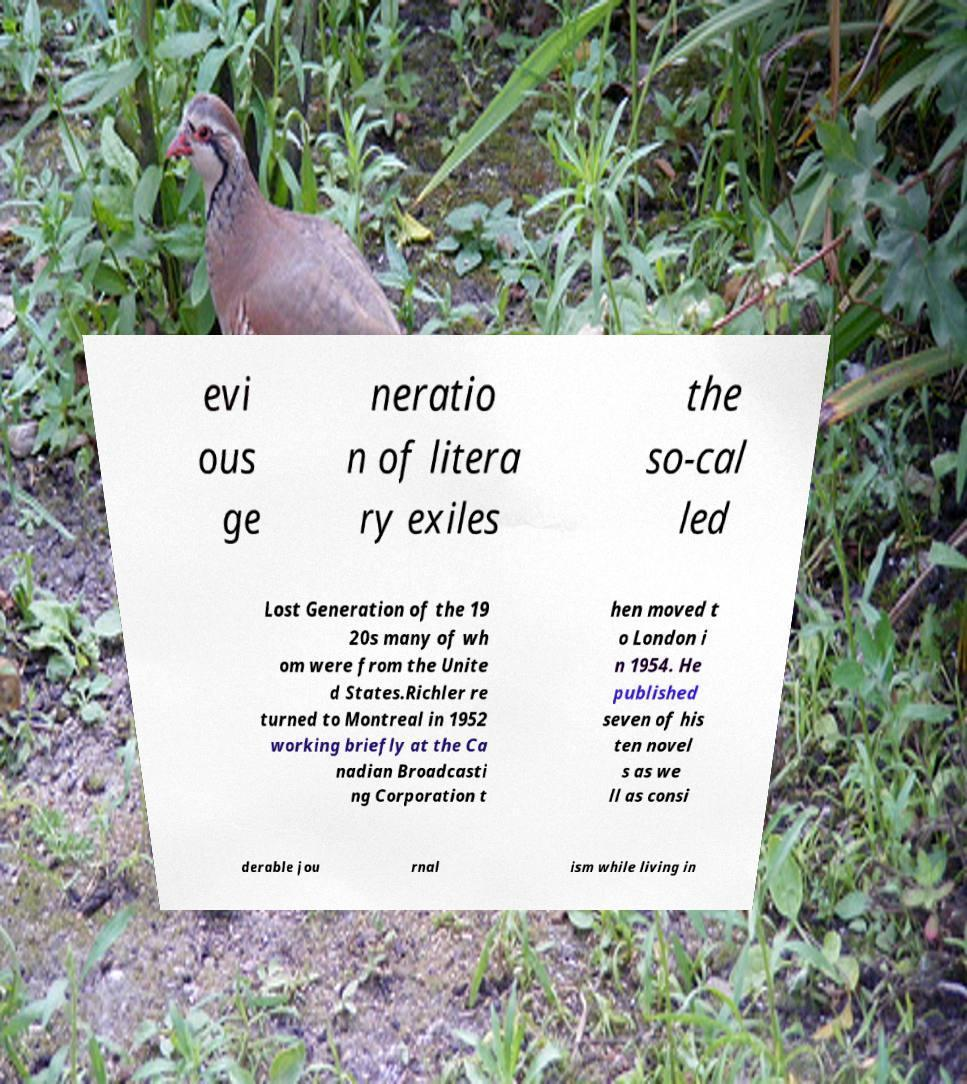What messages or text are displayed in this image? I need them in a readable, typed format. evi ous ge neratio n of litera ry exiles the so-cal led Lost Generation of the 19 20s many of wh om were from the Unite d States.Richler re turned to Montreal in 1952 working briefly at the Ca nadian Broadcasti ng Corporation t hen moved t o London i n 1954. He published seven of his ten novel s as we ll as consi derable jou rnal ism while living in 